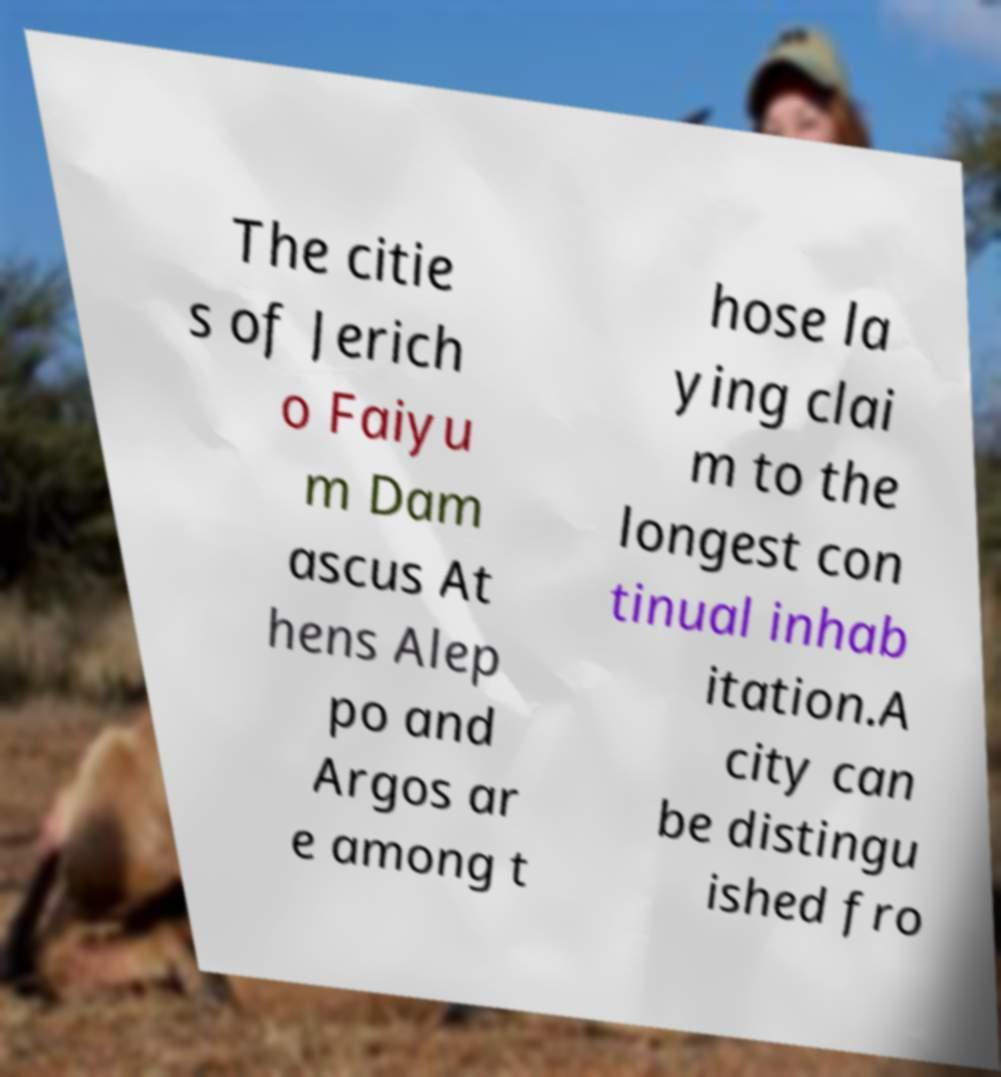Could you extract and type out the text from this image? The citie s of Jerich o Faiyu m Dam ascus At hens Alep po and Argos ar e among t hose la ying clai m to the longest con tinual inhab itation.A city can be distingu ished fro 